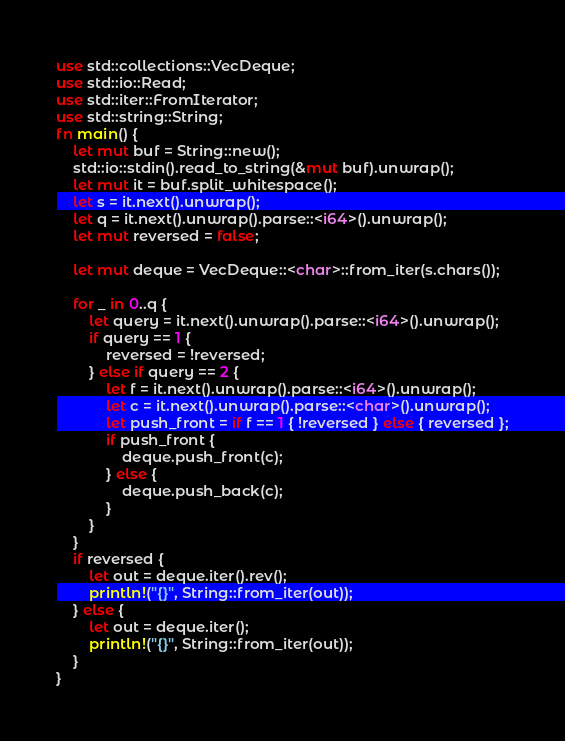Convert code to text. <code><loc_0><loc_0><loc_500><loc_500><_Rust_>use std::collections::VecDeque;
use std::io::Read;
use std::iter::FromIterator;
use std::string::String;
fn main() {
    let mut buf = String::new();
    std::io::stdin().read_to_string(&mut buf).unwrap();
    let mut it = buf.split_whitespace();
    let s = it.next().unwrap();
    let q = it.next().unwrap().parse::<i64>().unwrap();
    let mut reversed = false;

    let mut deque = VecDeque::<char>::from_iter(s.chars());

    for _ in 0..q {
        let query = it.next().unwrap().parse::<i64>().unwrap();
        if query == 1 {
            reversed = !reversed;
        } else if query == 2 {
            let f = it.next().unwrap().parse::<i64>().unwrap();
            let c = it.next().unwrap().parse::<char>().unwrap();
            let push_front = if f == 1 { !reversed } else { reversed };
            if push_front {
                deque.push_front(c);
            } else {
                deque.push_back(c);
            }
        }
    }
    if reversed {
        let out = deque.iter().rev();
        println!("{}", String::from_iter(out));
    } else {
        let out = deque.iter();
        println!("{}", String::from_iter(out));
    }
}
</code> 